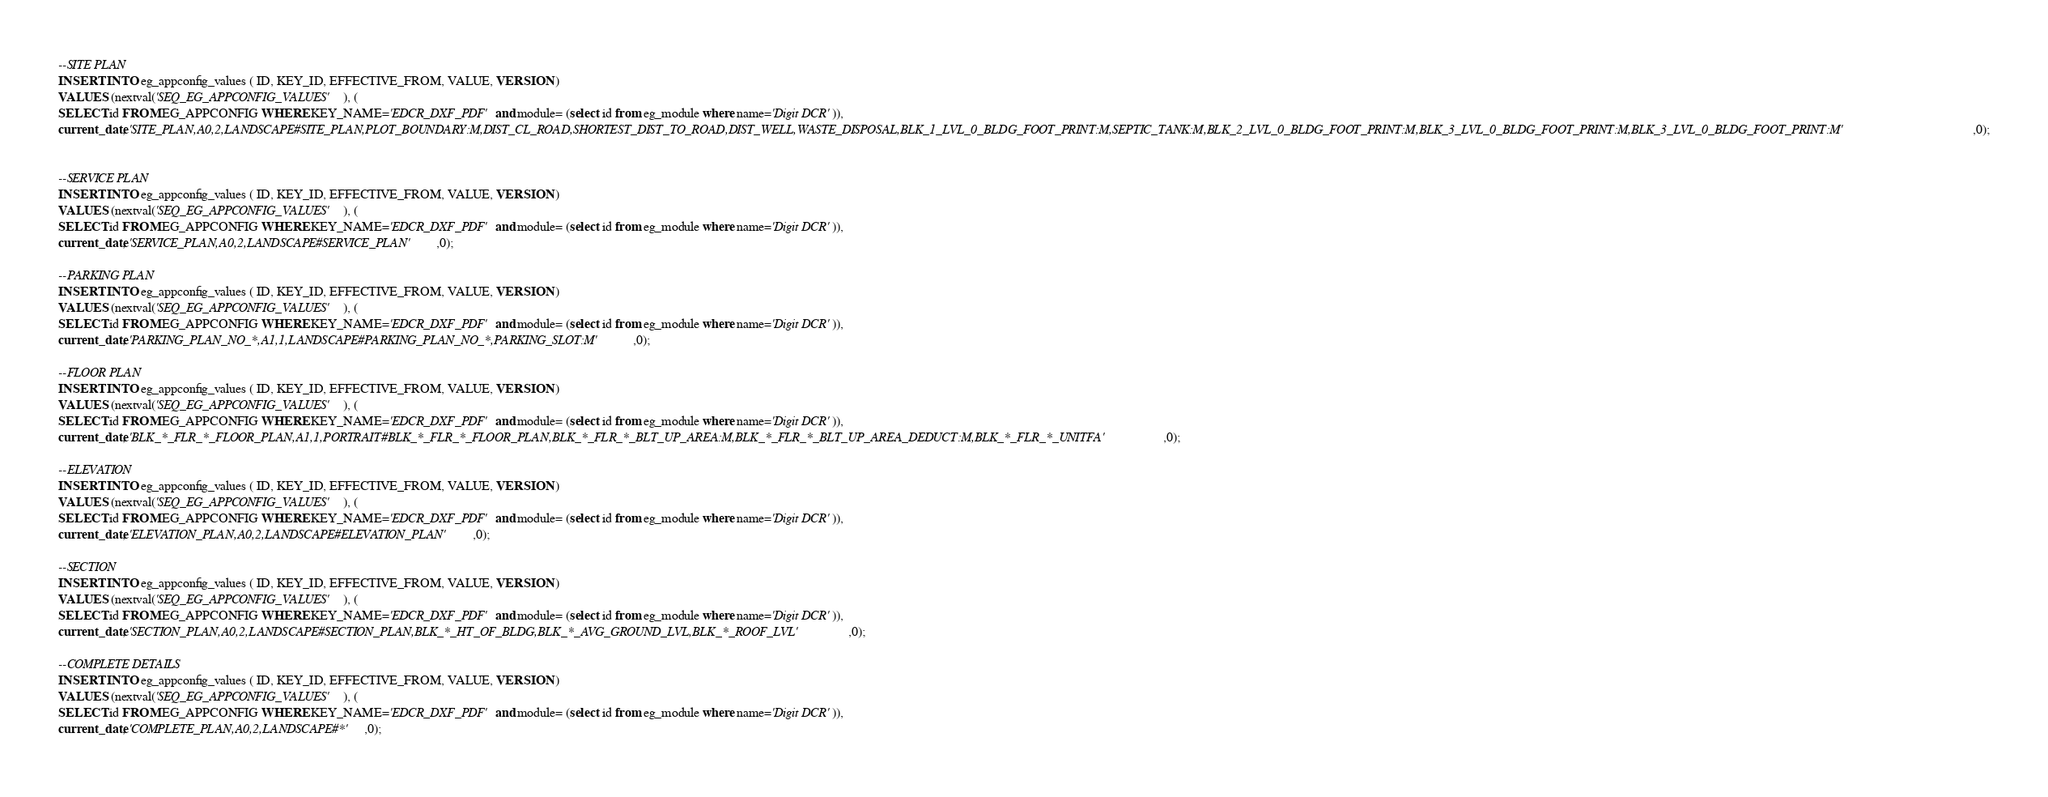Convert code to text. <code><loc_0><loc_0><loc_500><loc_500><_SQL_>
--SITE PLAN
INSERT INTO eg_appconfig_values ( ID, KEY_ID, EFFECTIVE_FROM, VALUE, VERSION )
VALUES (nextval('SEQ_EG_APPCONFIG_VALUES'), (
SELECT id FROM EG_APPCONFIG WHERE KEY_NAME='EDCR_DXF_PDF' and module= (select id from eg_module where name='Digit DCR')),
current_date, 'SITE_PLAN,A0,2,LANDSCAPE#SITE_PLAN,PLOT_BOUNDARY:M,DIST_CL_ROAD,SHORTEST_DIST_TO_ROAD,DIST_WELL,WASTE_DISPOSAL,BLK_1_LVL_0_BLDG_FOOT_PRINT:M,SEPTIC_TANK:M,BLK_2_LVL_0_BLDG_FOOT_PRINT:M,BLK_3_LVL_0_BLDG_FOOT_PRINT:M,BLK_3_LVL_0_BLDG_FOOT_PRINT:M',0);


--SERVICE PLAN
INSERT INTO eg_appconfig_values ( ID, KEY_ID, EFFECTIVE_FROM, VALUE, VERSION )
VALUES (nextval('SEQ_EG_APPCONFIG_VALUES'), (
SELECT id FROM EG_APPCONFIG WHERE KEY_NAME='EDCR_DXF_PDF' and module= (select id from eg_module where name='Digit DCR')),
current_date, 'SERVICE_PLAN,A0,2,LANDSCAPE#SERVICE_PLAN',0);

--PARKING PLAN
INSERT INTO eg_appconfig_values ( ID, KEY_ID, EFFECTIVE_FROM, VALUE, VERSION )
VALUES (nextval('SEQ_EG_APPCONFIG_VALUES'), (
SELECT id FROM EG_APPCONFIG WHERE KEY_NAME='EDCR_DXF_PDF' and module= (select id from eg_module where name='Digit DCR')),
current_date, 'PARKING_PLAN_NO_*,A1,1,LANDSCAPE#PARKING_PLAN_NO_*,PARKING_SLOT:M',0);

--FLOOR PLAN
INSERT INTO eg_appconfig_values ( ID, KEY_ID, EFFECTIVE_FROM, VALUE, VERSION )
VALUES (nextval('SEQ_EG_APPCONFIG_VALUES'), (
SELECT id FROM EG_APPCONFIG WHERE KEY_NAME='EDCR_DXF_PDF' and module= (select id from eg_module where name='Digit DCR')),
current_date, 'BLK_*_FLR_*_FLOOR_PLAN,A1,1,PORTRAIT#BLK_*_FLR_*_FLOOR_PLAN,BLK_*_FLR_*_BLT_UP_AREA:M,BLK_*_FLR_*_BLT_UP_AREA_DEDUCT:M,BLK_*_FLR_*_UNITFA',0);

--ELEVATION
INSERT INTO eg_appconfig_values ( ID, KEY_ID, EFFECTIVE_FROM, VALUE, VERSION )
VALUES (nextval('SEQ_EG_APPCONFIG_VALUES'), (
SELECT id FROM EG_APPCONFIG WHERE KEY_NAME='EDCR_DXF_PDF' and module= (select id from eg_module where name='Digit DCR')),
current_date, 'ELEVATION_PLAN,A0,2,LANDSCAPE#ELEVATION_PLAN',0);

--SECTION
INSERT INTO eg_appconfig_values ( ID, KEY_ID, EFFECTIVE_FROM, VALUE, VERSION )
VALUES (nextval('SEQ_EG_APPCONFIG_VALUES'), (
SELECT id FROM EG_APPCONFIG WHERE KEY_NAME='EDCR_DXF_PDF' and module= (select id from eg_module where name='Digit DCR')),
current_date, 'SECTION_PLAN,A0,2,LANDSCAPE#SECTION_PLAN,BLK_*_HT_OF_BLDG,BLK_*_AVG_GROUND_LVL,BLK_*_ROOF_LVL',0);

--COMPLETE DETAILS
INSERT INTO eg_appconfig_values ( ID, KEY_ID, EFFECTIVE_FROM, VALUE, VERSION )
VALUES (nextval('SEQ_EG_APPCONFIG_VALUES'), (
SELECT id FROM EG_APPCONFIG WHERE KEY_NAME='EDCR_DXF_PDF' and module= (select id from eg_module where name='Digit DCR')),
current_date, 'COMPLETE_PLAN,A0,2,LANDSCAPE#*',0);


</code> 